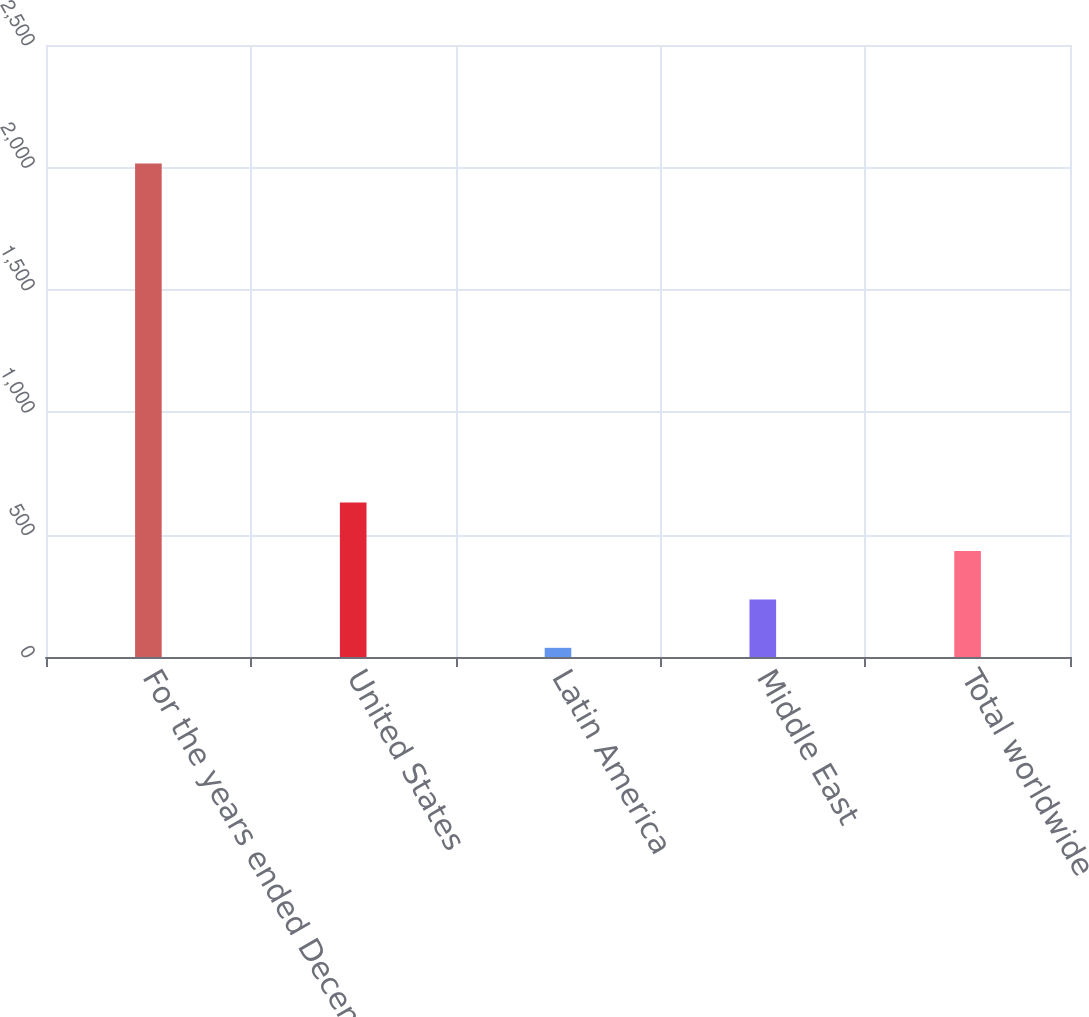Convert chart to OTSL. <chart><loc_0><loc_0><loc_500><loc_500><bar_chart><fcel>For the years ended December<fcel>United States<fcel>Latin America<fcel>Middle East<fcel>Total worldwide<nl><fcel>2016<fcel>631.03<fcel>37.48<fcel>235.33<fcel>433.18<nl></chart> 